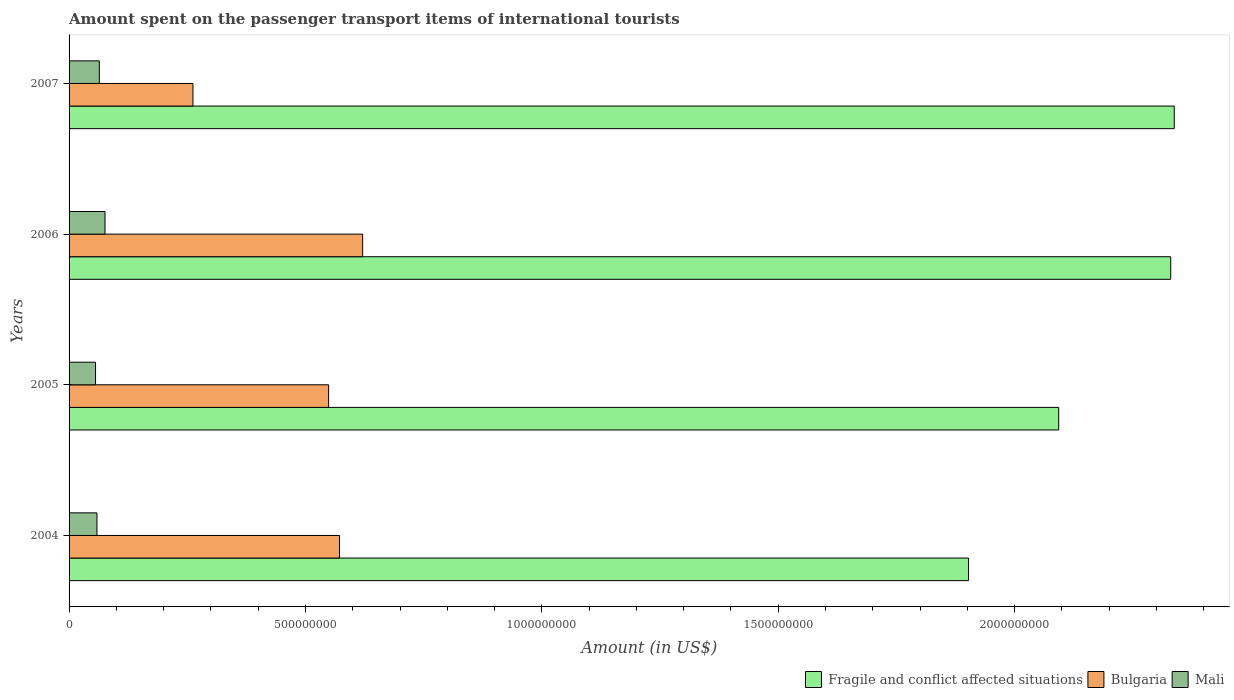How many bars are there on the 4th tick from the top?
Your response must be concise. 3. How many bars are there on the 3rd tick from the bottom?
Offer a very short reply. 3. In how many cases, is the number of bars for a given year not equal to the number of legend labels?
Make the answer very short. 0. What is the amount spent on the passenger transport items of international tourists in Fragile and conflict affected situations in 2007?
Make the answer very short. 2.34e+09. Across all years, what is the maximum amount spent on the passenger transport items of international tourists in Bulgaria?
Your answer should be compact. 6.21e+08. Across all years, what is the minimum amount spent on the passenger transport items of international tourists in Fragile and conflict affected situations?
Your response must be concise. 1.90e+09. What is the total amount spent on the passenger transport items of international tourists in Mali in the graph?
Offer a very short reply. 2.55e+08. What is the difference between the amount spent on the passenger transport items of international tourists in Mali in 2004 and that in 2007?
Provide a short and direct response. -5.00e+06. What is the difference between the amount spent on the passenger transport items of international tourists in Mali in 2004 and the amount spent on the passenger transport items of international tourists in Bulgaria in 2005?
Make the answer very short. -4.90e+08. What is the average amount spent on the passenger transport items of international tourists in Fragile and conflict affected situations per year?
Your answer should be compact. 2.17e+09. In the year 2006, what is the difference between the amount spent on the passenger transport items of international tourists in Fragile and conflict affected situations and amount spent on the passenger transport items of international tourists in Mali?
Provide a short and direct response. 2.25e+09. What is the ratio of the amount spent on the passenger transport items of international tourists in Bulgaria in 2004 to that in 2007?
Your answer should be very brief. 2.18. Is the amount spent on the passenger transport items of international tourists in Mali in 2005 less than that in 2007?
Give a very brief answer. Yes. Is the difference between the amount spent on the passenger transport items of international tourists in Fragile and conflict affected situations in 2005 and 2007 greater than the difference between the amount spent on the passenger transport items of international tourists in Mali in 2005 and 2007?
Your answer should be very brief. No. What is the difference between the highest and the second highest amount spent on the passenger transport items of international tourists in Fragile and conflict affected situations?
Offer a very short reply. 7.46e+06. What does the 3rd bar from the top in 2007 represents?
Make the answer very short. Fragile and conflict affected situations. What does the 1st bar from the bottom in 2005 represents?
Your answer should be compact. Fragile and conflict affected situations. Is it the case that in every year, the sum of the amount spent on the passenger transport items of international tourists in Mali and amount spent on the passenger transport items of international tourists in Bulgaria is greater than the amount spent on the passenger transport items of international tourists in Fragile and conflict affected situations?
Your response must be concise. No. How many bars are there?
Provide a succinct answer. 12. How many years are there in the graph?
Your answer should be very brief. 4. What is the difference between two consecutive major ticks on the X-axis?
Provide a short and direct response. 5.00e+08. Does the graph contain any zero values?
Offer a very short reply. No. Does the graph contain grids?
Give a very brief answer. No. Where does the legend appear in the graph?
Offer a terse response. Bottom right. What is the title of the graph?
Provide a succinct answer. Amount spent on the passenger transport items of international tourists. What is the Amount (in US$) in Fragile and conflict affected situations in 2004?
Provide a short and direct response. 1.90e+09. What is the Amount (in US$) in Bulgaria in 2004?
Make the answer very short. 5.72e+08. What is the Amount (in US$) of Mali in 2004?
Your response must be concise. 5.90e+07. What is the Amount (in US$) of Fragile and conflict affected situations in 2005?
Keep it short and to the point. 2.09e+09. What is the Amount (in US$) in Bulgaria in 2005?
Provide a short and direct response. 5.49e+08. What is the Amount (in US$) of Mali in 2005?
Your response must be concise. 5.60e+07. What is the Amount (in US$) in Fragile and conflict affected situations in 2006?
Your answer should be compact. 2.33e+09. What is the Amount (in US$) in Bulgaria in 2006?
Make the answer very short. 6.21e+08. What is the Amount (in US$) in Mali in 2006?
Your answer should be very brief. 7.60e+07. What is the Amount (in US$) in Fragile and conflict affected situations in 2007?
Offer a very short reply. 2.34e+09. What is the Amount (in US$) of Bulgaria in 2007?
Make the answer very short. 2.62e+08. What is the Amount (in US$) in Mali in 2007?
Offer a very short reply. 6.40e+07. Across all years, what is the maximum Amount (in US$) of Fragile and conflict affected situations?
Provide a succinct answer. 2.34e+09. Across all years, what is the maximum Amount (in US$) of Bulgaria?
Ensure brevity in your answer.  6.21e+08. Across all years, what is the maximum Amount (in US$) of Mali?
Your answer should be compact. 7.60e+07. Across all years, what is the minimum Amount (in US$) of Fragile and conflict affected situations?
Your answer should be very brief. 1.90e+09. Across all years, what is the minimum Amount (in US$) of Bulgaria?
Ensure brevity in your answer.  2.62e+08. Across all years, what is the minimum Amount (in US$) of Mali?
Your response must be concise. 5.60e+07. What is the total Amount (in US$) of Fragile and conflict affected situations in the graph?
Offer a terse response. 8.66e+09. What is the total Amount (in US$) of Bulgaria in the graph?
Provide a succinct answer. 2.00e+09. What is the total Amount (in US$) in Mali in the graph?
Your response must be concise. 2.55e+08. What is the difference between the Amount (in US$) in Fragile and conflict affected situations in 2004 and that in 2005?
Offer a very short reply. -1.91e+08. What is the difference between the Amount (in US$) of Bulgaria in 2004 and that in 2005?
Give a very brief answer. 2.30e+07. What is the difference between the Amount (in US$) in Mali in 2004 and that in 2005?
Offer a very short reply. 3.00e+06. What is the difference between the Amount (in US$) of Fragile and conflict affected situations in 2004 and that in 2006?
Provide a succinct answer. -4.28e+08. What is the difference between the Amount (in US$) of Bulgaria in 2004 and that in 2006?
Offer a terse response. -4.90e+07. What is the difference between the Amount (in US$) in Mali in 2004 and that in 2006?
Make the answer very short. -1.70e+07. What is the difference between the Amount (in US$) of Fragile and conflict affected situations in 2004 and that in 2007?
Your answer should be compact. -4.35e+08. What is the difference between the Amount (in US$) of Bulgaria in 2004 and that in 2007?
Ensure brevity in your answer.  3.10e+08. What is the difference between the Amount (in US$) in Mali in 2004 and that in 2007?
Offer a very short reply. -5.00e+06. What is the difference between the Amount (in US$) of Fragile and conflict affected situations in 2005 and that in 2006?
Make the answer very short. -2.37e+08. What is the difference between the Amount (in US$) of Bulgaria in 2005 and that in 2006?
Your answer should be very brief. -7.20e+07. What is the difference between the Amount (in US$) of Mali in 2005 and that in 2006?
Offer a terse response. -2.00e+07. What is the difference between the Amount (in US$) in Fragile and conflict affected situations in 2005 and that in 2007?
Your answer should be compact. -2.44e+08. What is the difference between the Amount (in US$) in Bulgaria in 2005 and that in 2007?
Provide a succinct answer. 2.87e+08. What is the difference between the Amount (in US$) of Mali in 2005 and that in 2007?
Ensure brevity in your answer.  -8.00e+06. What is the difference between the Amount (in US$) in Fragile and conflict affected situations in 2006 and that in 2007?
Keep it short and to the point. -7.46e+06. What is the difference between the Amount (in US$) of Bulgaria in 2006 and that in 2007?
Provide a succinct answer. 3.59e+08. What is the difference between the Amount (in US$) of Mali in 2006 and that in 2007?
Keep it short and to the point. 1.20e+07. What is the difference between the Amount (in US$) of Fragile and conflict affected situations in 2004 and the Amount (in US$) of Bulgaria in 2005?
Your response must be concise. 1.35e+09. What is the difference between the Amount (in US$) in Fragile and conflict affected situations in 2004 and the Amount (in US$) in Mali in 2005?
Offer a very short reply. 1.85e+09. What is the difference between the Amount (in US$) of Bulgaria in 2004 and the Amount (in US$) of Mali in 2005?
Provide a short and direct response. 5.16e+08. What is the difference between the Amount (in US$) of Fragile and conflict affected situations in 2004 and the Amount (in US$) of Bulgaria in 2006?
Offer a terse response. 1.28e+09. What is the difference between the Amount (in US$) in Fragile and conflict affected situations in 2004 and the Amount (in US$) in Mali in 2006?
Provide a succinct answer. 1.83e+09. What is the difference between the Amount (in US$) of Bulgaria in 2004 and the Amount (in US$) of Mali in 2006?
Offer a terse response. 4.96e+08. What is the difference between the Amount (in US$) in Fragile and conflict affected situations in 2004 and the Amount (in US$) in Bulgaria in 2007?
Ensure brevity in your answer.  1.64e+09. What is the difference between the Amount (in US$) of Fragile and conflict affected situations in 2004 and the Amount (in US$) of Mali in 2007?
Ensure brevity in your answer.  1.84e+09. What is the difference between the Amount (in US$) of Bulgaria in 2004 and the Amount (in US$) of Mali in 2007?
Make the answer very short. 5.08e+08. What is the difference between the Amount (in US$) of Fragile and conflict affected situations in 2005 and the Amount (in US$) of Bulgaria in 2006?
Provide a short and direct response. 1.47e+09. What is the difference between the Amount (in US$) of Fragile and conflict affected situations in 2005 and the Amount (in US$) of Mali in 2006?
Your response must be concise. 2.02e+09. What is the difference between the Amount (in US$) of Bulgaria in 2005 and the Amount (in US$) of Mali in 2006?
Offer a very short reply. 4.73e+08. What is the difference between the Amount (in US$) of Fragile and conflict affected situations in 2005 and the Amount (in US$) of Bulgaria in 2007?
Your answer should be compact. 1.83e+09. What is the difference between the Amount (in US$) of Fragile and conflict affected situations in 2005 and the Amount (in US$) of Mali in 2007?
Offer a terse response. 2.03e+09. What is the difference between the Amount (in US$) in Bulgaria in 2005 and the Amount (in US$) in Mali in 2007?
Offer a terse response. 4.85e+08. What is the difference between the Amount (in US$) of Fragile and conflict affected situations in 2006 and the Amount (in US$) of Bulgaria in 2007?
Give a very brief answer. 2.07e+09. What is the difference between the Amount (in US$) in Fragile and conflict affected situations in 2006 and the Amount (in US$) in Mali in 2007?
Offer a very short reply. 2.27e+09. What is the difference between the Amount (in US$) in Bulgaria in 2006 and the Amount (in US$) in Mali in 2007?
Give a very brief answer. 5.57e+08. What is the average Amount (in US$) of Fragile and conflict affected situations per year?
Offer a very short reply. 2.17e+09. What is the average Amount (in US$) of Bulgaria per year?
Give a very brief answer. 5.01e+08. What is the average Amount (in US$) of Mali per year?
Ensure brevity in your answer.  6.38e+07. In the year 2004, what is the difference between the Amount (in US$) of Fragile and conflict affected situations and Amount (in US$) of Bulgaria?
Make the answer very short. 1.33e+09. In the year 2004, what is the difference between the Amount (in US$) of Fragile and conflict affected situations and Amount (in US$) of Mali?
Your answer should be compact. 1.84e+09. In the year 2004, what is the difference between the Amount (in US$) in Bulgaria and Amount (in US$) in Mali?
Your answer should be very brief. 5.13e+08. In the year 2005, what is the difference between the Amount (in US$) in Fragile and conflict affected situations and Amount (in US$) in Bulgaria?
Offer a very short reply. 1.54e+09. In the year 2005, what is the difference between the Amount (in US$) in Fragile and conflict affected situations and Amount (in US$) in Mali?
Make the answer very short. 2.04e+09. In the year 2005, what is the difference between the Amount (in US$) of Bulgaria and Amount (in US$) of Mali?
Your answer should be very brief. 4.93e+08. In the year 2006, what is the difference between the Amount (in US$) of Fragile and conflict affected situations and Amount (in US$) of Bulgaria?
Ensure brevity in your answer.  1.71e+09. In the year 2006, what is the difference between the Amount (in US$) of Fragile and conflict affected situations and Amount (in US$) of Mali?
Provide a succinct answer. 2.25e+09. In the year 2006, what is the difference between the Amount (in US$) in Bulgaria and Amount (in US$) in Mali?
Keep it short and to the point. 5.45e+08. In the year 2007, what is the difference between the Amount (in US$) in Fragile and conflict affected situations and Amount (in US$) in Bulgaria?
Offer a very short reply. 2.08e+09. In the year 2007, what is the difference between the Amount (in US$) of Fragile and conflict affected situations and Amount (in US$) of Mali?
Give a very brief answer. 2.27e+09. In the year 2007, what is the difference between the Amount (in US$) in Bulgaria and Amount (in US$) in Mali?
Keep it short and to the point. 1.98e+08. What is the ratio of the Amount (in US$) of Fragile and conflict affected situations in 2004 to that in 2005?
Make the answer very short. 0.91. What is the ratio of the Amount (in US$) of Bulgaria in 2004 to that in 2005?
Keep it short and to the point. 1.04. What is the ratio of the Amount (in US$) of Mali in 2004 to that in 2005?
Your answer should be very brief. 1.05. What is the ratio of the Amount (in US$) of Fragile and conflict affected situations in 2004 to that in 2006?
Give a very brief answer. 0.82. What is the ratio of the Amount (in US$) in Bulgaria in 2004 to that in 2006?
Provide a short and direct response. 0.92. What is the ratio of the Amount (in US$) of Mali in 2004 to that in 2006?
Offer a terse response. 0.78. What is the ratio of the Amount (in US$) in Fragile and conflict affected situations in 2004 to that in 2007?
Offer a terse response. 0.81. What is the ratio of the Amount (in US$) in Bulgaria in 2004 to that in 2007?
Provide a short and direct response. 2.18. What is the ratio of the Amount (in US$) of Mali in 2004 to that in 2007?
Give a very brief answer. 0.92. What is the ratio of the Amount (in US$) in Fragile and conflict affected situations in 2005 to that in 2006?
Make the answer very short. 0.9. What is the ratio of the Amount (in US$) in Bulgaria in 2005 to that in 2006?
Provide a short and direct response. 0.88. What is the ratio of the Amount (in US$) of Mali in 2005 to that in 2006?
Provide a succinct answer. 0.74. What is the ratio of the Amount (in US$) in Fragile and conflict affected situations in 2005 to that in 2007?
Provide a succinct answer. 0.9. What is the ratio of the Amount (in US$) of Bulgaria in 2005 to that in 2007?
Offer a very short reply. 2.1. What is the ratio of the Amount (in US$) in Fragile and conflict affected situations in 2006 to that in 2007?
Offer a terse response. 1. What is the ratio of the Amount (in US$) of Bulgaria in 2006 to that in 2007?
Make the answer very short. 2.37. What is the ratio of the Amount (in US$) in Mali in 2006 to that in 2007?
Give a very brief answer. 1.19. What is the difference between the highest and the second highest Amount (in US$) of Fragile and conflict affected situations?
Your answer should be very brief. 7.46e+06. What is the difference between the highest and the second highest Amount (in US$) of Bulgaria?
Your answer should be very brief. 4.90e+07. What is the difference between the highest and the lowest Amount (in US$) of Fragile and conflict affected situations?
Your response must be concise. 4.35e+08. What is the difference between the highest and the lowest Amount (in US$) of Bulgaria?
Ensure brevity in your answer.  3.59e+08. 